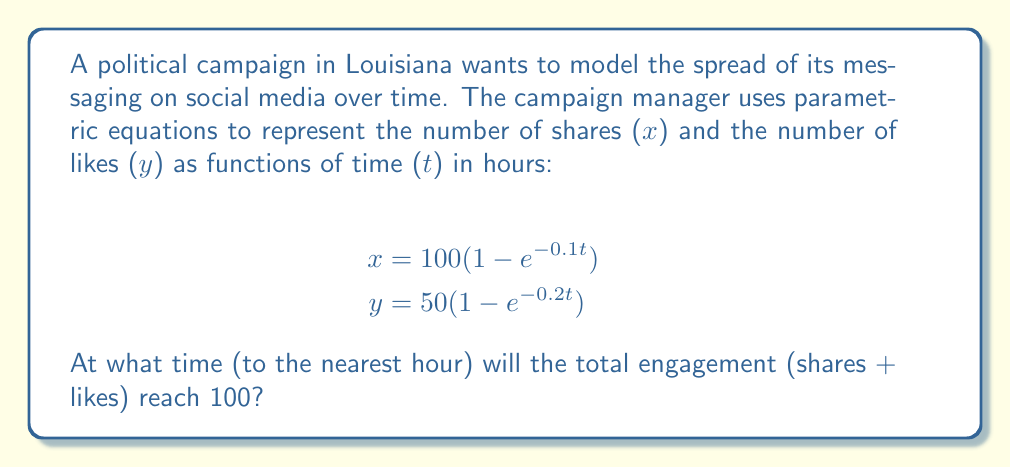Teach me how to tackle this problem. To solve this problem, we need to follow these steps:

1) The total engagement is the sum of shares (x) and likes (y).

2) We need to find t when x + y = 100.

3) Let's set up the equation:

   $$100(1 - e^{-0.1t}) + 50(1 - e^{-0.2t}) = 100$$

4) Simplify:

   $$100 - 100e^{-0.1t} + 50 - 50e^{-0.2t} = 100$$
   $$150 - 100e^{-0.1t} - 50e^{-0.2t} = 100$$
   $$-100e^{-0.1t} - 50e^{-0.2t} = -50$$

5) This equation cannot be solved algebraically. We need to use numerical methods or graphing to find the solution.

6) Using a graphing calculator or computer software, we can plot the left side of the equation:

   $$f(t) = -100e^{-0.1t} - 50e^{-0.2t} + 50$$

   and find where it crosses the x-axis.

7) The solution is approximately t ≈ 7.68 hours.

8) Rounding to the nearest hour gives us 8 hours.
Answer: 8 hours 